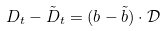Convert formula to latex. <formula><loc_0><loc_0><loc_500><loc_500>D _ { t } - \tilde { D } _ { t } = ( b - \tilde { b } ) \cdot \mathcal { D }</formula> 